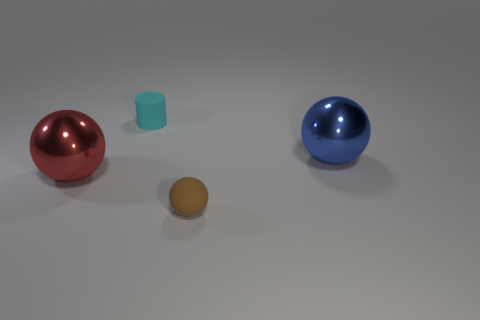Add 2 big blue metallic blocks. How many objects exist? 6 Subtract all balls. How many objects are left? 1 Subtract 0 gray cylinders. How many objects are left? 4 Subtract all tiny brown objects. Subtract all shiny objects. How many objects are left? 1 Add 2 tiny matte balls. How many tiny matte balls are left? 3 Add 1 large purple shiny spheres. How many large purple shiny spheres exist? 1 